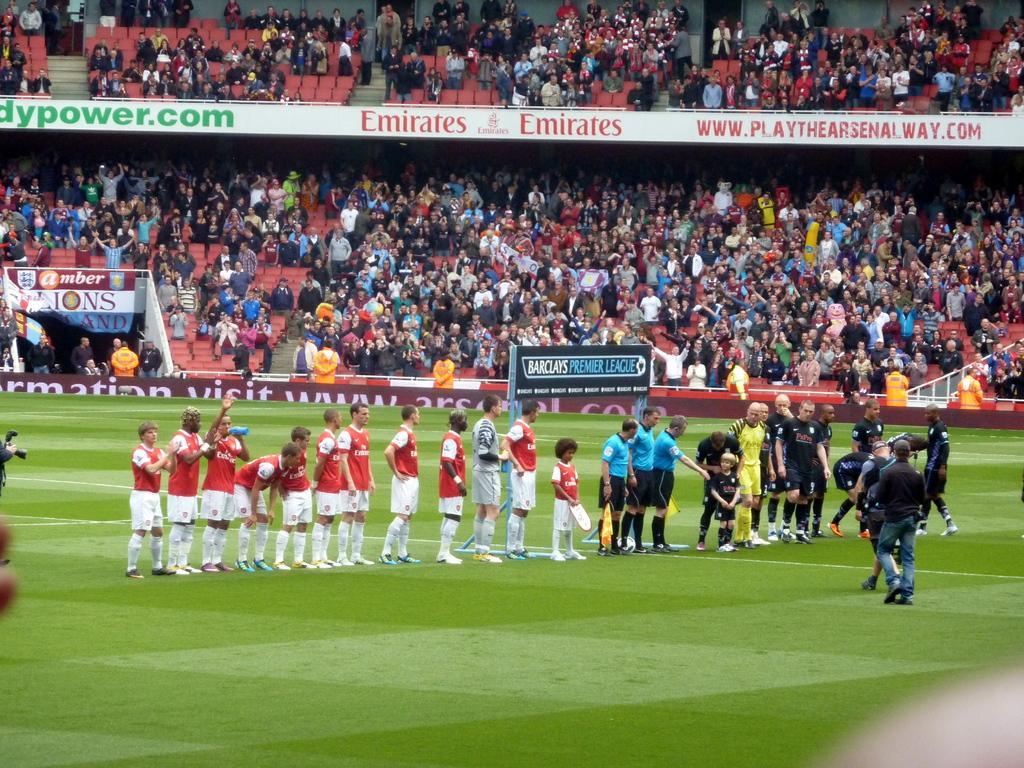<image>
Render a clear and concise summary of the photo. Two teams of young athletes gather on the field representing Barclays premier league and the stadium is packed. 